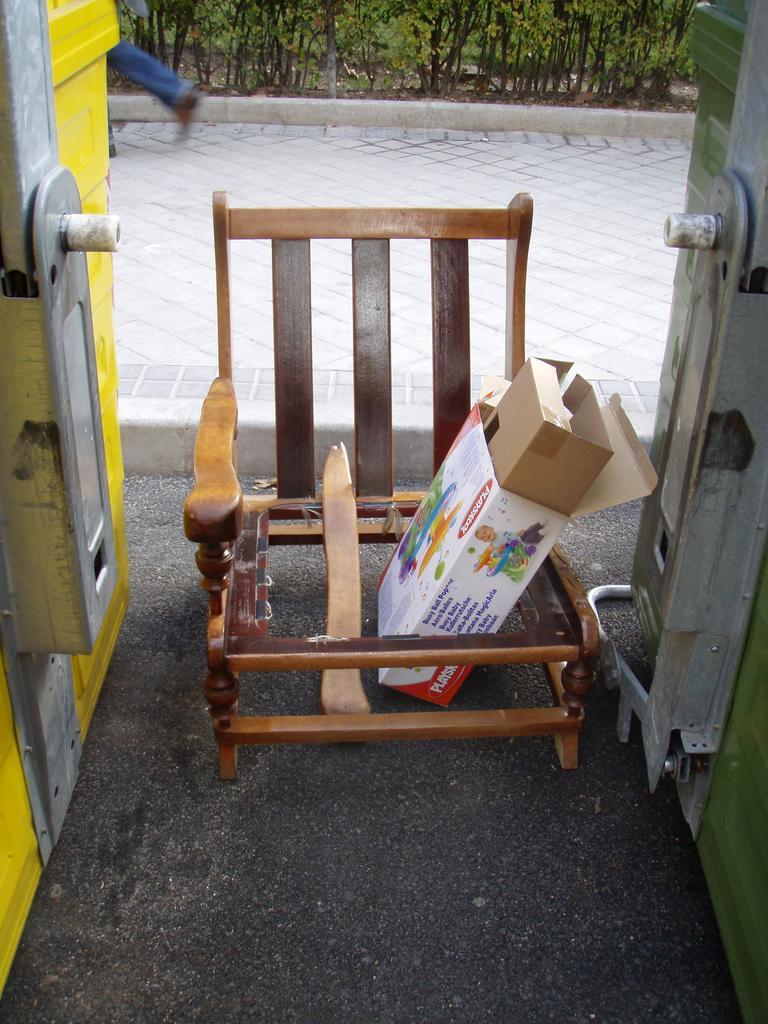Can you describe this image briefly? The image is taken on the streets. In the center of the image there is a broken chair and boxes. In the background there is a walkway and plants. 